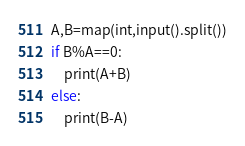<code> <loc_0><loc_0><loc_500><loc_500><_Python_>A,B=map(int,input().split())
if B%A==0:
    print(A+B)
else:
    print(B-A)</code> 